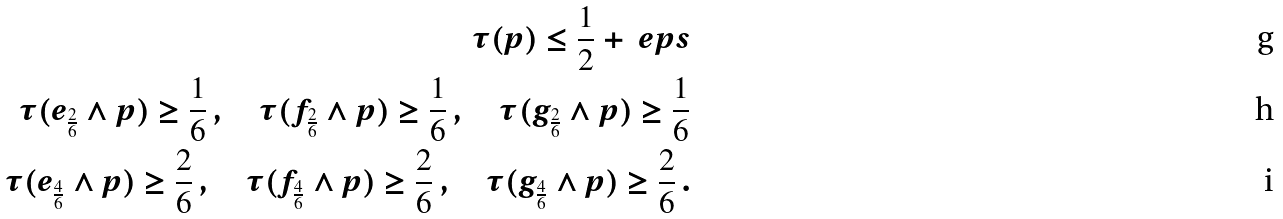Convert formula to latex. <formula><loc_0><loc_0><loc_500><loc_500>\tau ( p ) \leq \frac { 1 } { 2 } + \ e p s \\ \tau ( e _ { \frac { 2 } { 6 } } \wedge p ) \geq \frac { 1 } { 6 } \, , \quad \tau ( f _ { \frac { 2 } { 6 } } \wedge p ) \geq \frac { 1 } { 6 } \, , \quad \tau ( g _ { \frac { 2 } { 6 } } \wedge p ) \geq \frac { 1 } { 6 } \\ \tau ( e _ { \frac { 4 } { 6 } } \wedge p ) \geq \frac { 2 } { 6 } \, , \quad \tau ( f _ { \frac { 4 } { 6 } } \wedge p ) \geq \frac { 2 } { 6 } \, , \quad \tau ( g _ { \frac { 4 } { 6 } } \wedge p ) \geq \frac { 2 } { 6 } \, .</formula> 